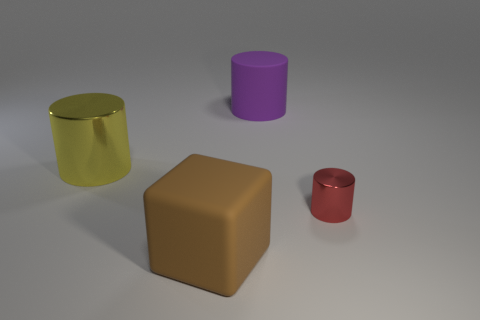Are there any shiny objects of the same color as the big block?
Provide a short and direct response. No. There is a cylinder on the right side of the rubber object that is to the right of the big brown rubber cube; what color is it?
Provide a short and direct response. Red. Is the number of large brown rubber objects that are right of the large matte cylinder less than the number of big matte cylinders that are on the left side of the block?
Give a very brief answer. No. Is the size of the purple matte thing the same as the red metallic cylinder?
Make the answer very short. No. What shape is the thing that is to the left of the rubber cylinder and in front of the big yellow metallic thing?
Your answer should be very brief. Cube. How many other cylinders are made of the same material as the tiny red cylinder?
Ensure brevity in your answer.  1. There is a shiny cylinder that is on the right side of the large yellow metal cylinder; how many objects are in front of it?
Offer a very short reply. 1. There is a large rubber object that is in front of the big thing that is right of the big rubber object that is in front of the tiny red cylinder; what shape is it?
Your response must be concise. Cube. How many things are either cyan metal cylinders or big yellow metal cylinders?
Offer a terse response. 1. What is the color of the block that is the same size as the matte cylinder?
Provide a succinct answer. Brown. 